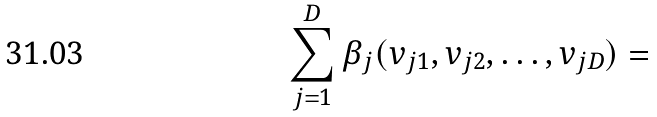<formula> <loc_0><loc_0><loc_500><loc_500>\sum _ { j = 1 } ^ { D } \beta _ { j } ( v _ { j 1 } , v _ { j 2 } , \dots , v _ { j D } ) =</formula> 